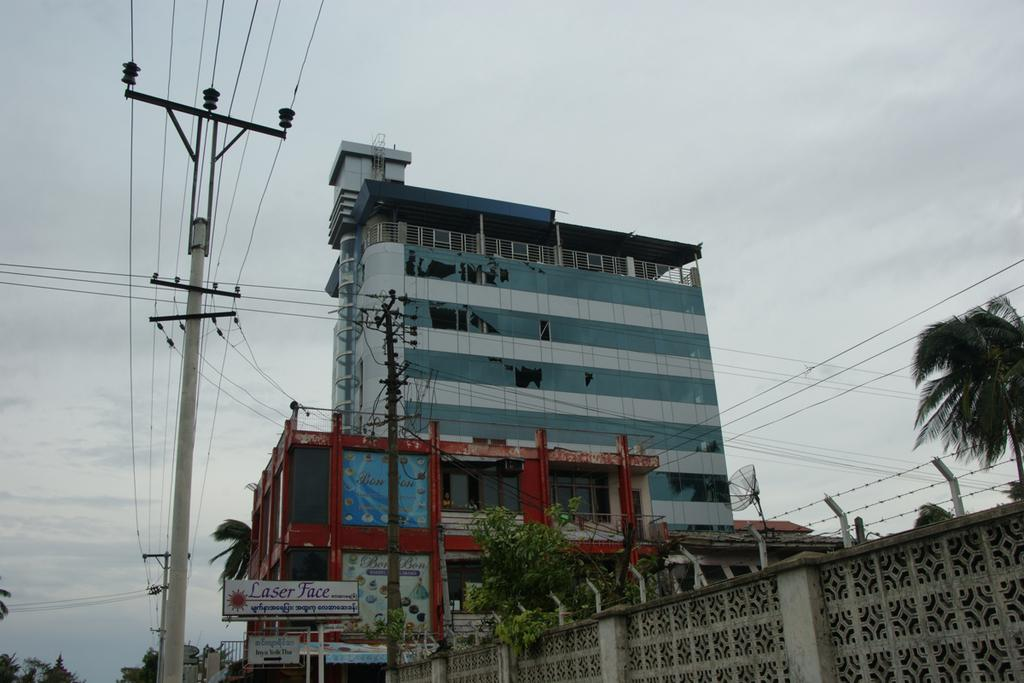What type of structures can be seen in the image? There are buildings in the image. What other elements are present in the image besides buildings? There are trees, banners, poles, electric wires, and the sky visible in the background. Can you describe the sky in the image? The sky is visible in the background of the image, and clouds are present. What type of fruit can be seen growing on the trees in the image? There is no fruit visible on the trees in the image; only the trees themselves are present. What type of liquid is being used to water the plants in the image? There is no indication of plants being watered or any liquid present in the image. 